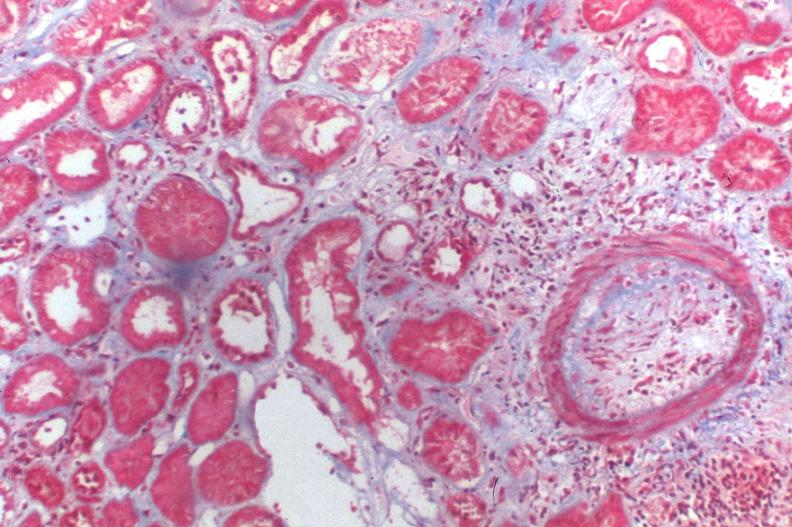does good example of muscle atrophy show kidney transplant rejection?
Answer the question using a single word or phrase. No 